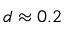Convert formula to latex. <formula><loc_0><loc_0><loc_500><loc_500>d \approx 0 . 2</formula> 